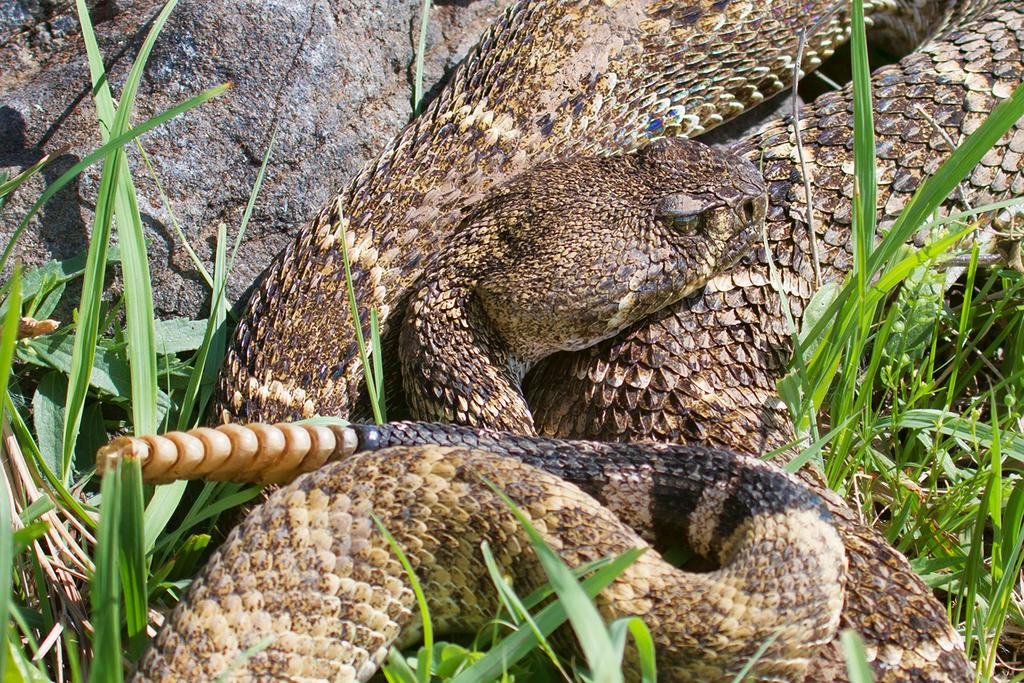What type of animal is in the picture? There is a snake in the picture. What is the color of the grass in the picture? There is green grass in the picture. What type of silk can be seen on the train in the picture? There is no train or silk present in the picture; it only features a snake and green grass. 